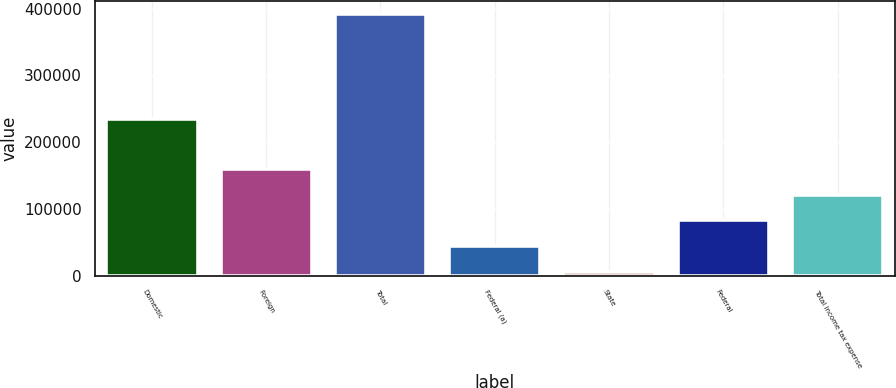Convert chart to OTSL. <chart><loc_0><loc_0><loc_500><loc_500><bar_chart><fcel>Domestic<fcel>Foreign<fcel>Total<fcel>Federal (a)<fcel>State<fcel>Federal<fcel>Total income tax expense<nl><fcel>235222<fcel>159976<fcel>392103<fcel>43911.9<fcel>5224<fcel>82599.8<fcel>121288<nl></chart> 